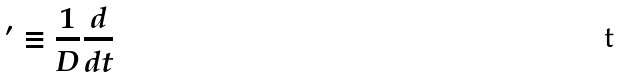Convert formula to latex. <formula><loc_0><loc_0><loc_500><loc_500>^ { \prime } \equiv \frac { 1 } { D } \frac { d } { d t }</formula> 